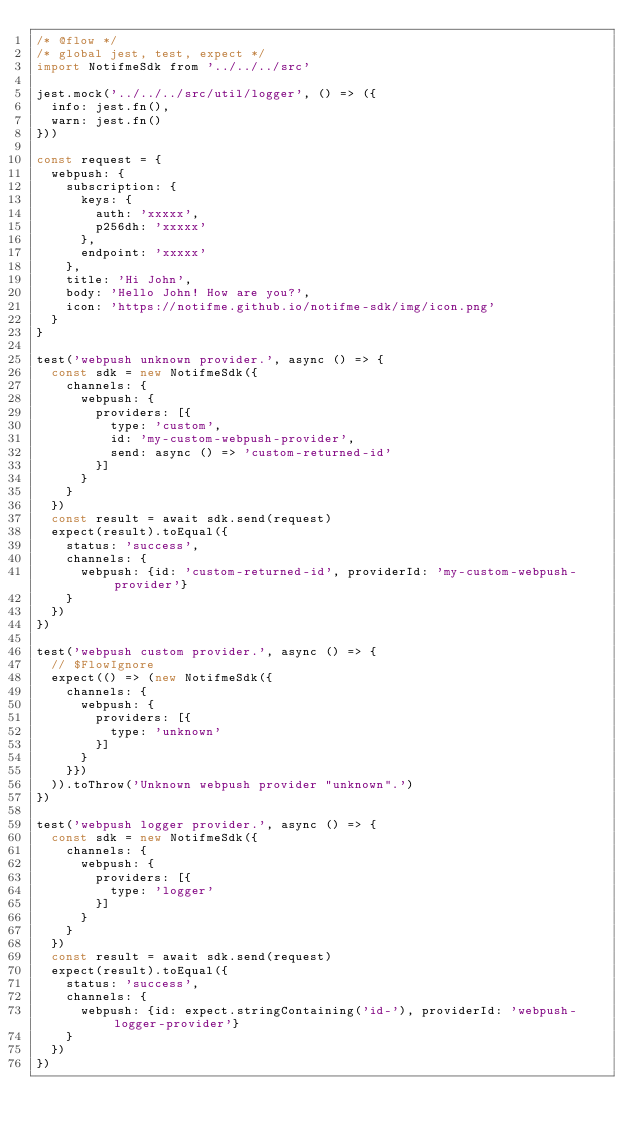Convert code to text. <code><loc_0><loc_0><loc_500><loc_500><_JavaScript_>/* @flow */
/* global jest, test, expect */
import NotifmeSdk from '../../../src'

jest.mock('../../../src/util/logger', () => ({
  info: jest.fn(),
  warn: jest.fn()
}))

const request = {
  webpush: {
    subscription: {
      keys: {
        auth: 'xxxxx',
        p256dh: 'xxxxx'
      },
      endpoint: 'xxxxx'
    },
    title: 'Hi John',
    body: 'Hello John! How are you?',
    icon: 'https://notifme.github.io/notifme-sdk/img/icon.png'
  }
}

test('webpush unknown provider.', async () => {
  const sdk = new NotifmeSdk({
    channels: {
      webpush: {
        providers: [{
          type: 'custom',
          id: 'my-custom-webpush-provider',
          send: async () => 'custom-returned-id'
        }]
      }
    }
  })
  const result = await sdk.send(request)
  expect(result).toEqual({
    status: 'success',
    channels: {
      webpush: {id: 'custom-returned-id', providerId: 'my-custom-webpush-provider'}
    }
  })
})

test('webpush custom provider.', async () => {
  // $FlowIgnore
  expect(() => (new NotifmeSdk({
    channels: {
      webpush: {
        providers: [{
          type: 'unknown'
        }]
      }
    }})
  )).toThrow('Unknown webpush provider "unknown".')
})

test('webpush logger provider.', async () => {
  const sdk = new NotifmeSdk({
    channels: {
      webpush: {
        providers: [{
          type: 'logger'
        }]
      }
    }
  })
  const result = await sdk.send(request)
  expect(result).toEqual({
    status: 'success',
    channels: {
      webpush: {id: expect.stringContaining('id-'), providerId: 'webpush-logger-provider'}
    }
  })
})
</code> 